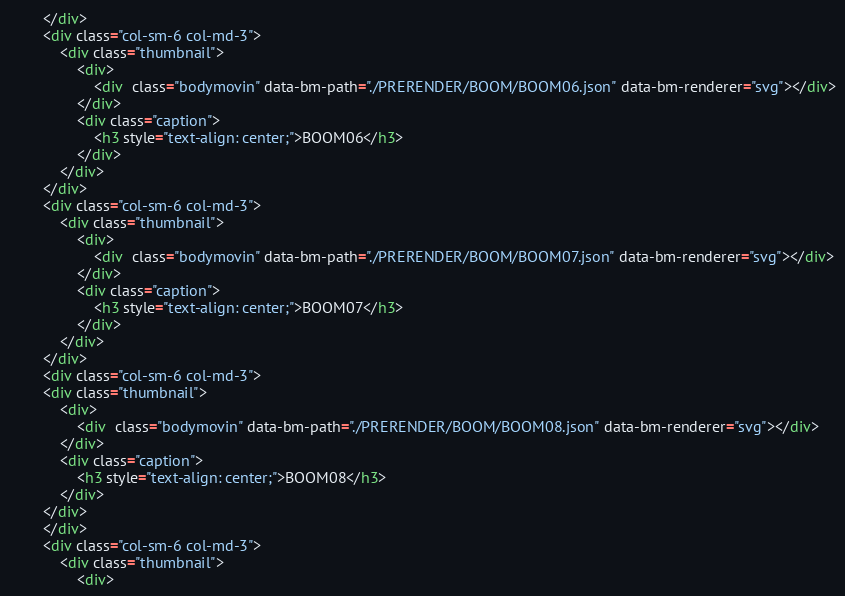Convert code to text. <code><loc_0><loc_0><loc_500><loc_500><_HTML_>        </div>
        <div class="col-sm-6 col-md-3">
            <div class="thumbnail">
                <div>
                    <div  class="bodymovin" data-bm-path="./PRERENDER/BOOM/BOOM06.json" data-bm-renderer="svg"></div>
                </div>
                <div class="caption">
                    <h3 style="text-align: center;">BOOM06</h3>
                </div>
            </div>
        </div>
        <div class="col-sm-6 col-md-3">
            <div class="thumbnail">
                <div>
                    <div  class="bodymovin" data-bm-path="./PRERENDER/BOOM/BOOM07.json" data-bm-renderer="svg"></div>
                </div>
                <div class="caption">
                    <h3 style="text-align: center;">BOOM07</h3>
                </div>
            </div>
        </div>
        <div class="col-sm-6 col-md-3">
        <div class="thumbnail">
            <div>
                <div  class="bodymovin" data-bm-path="./PRERENDER/BOOM/BOOM08.json" data-bm-renderer="svg"></div>
            </div>
            <div class="caption">
                <h3 style="text-align: center;">BOOM08</h3>
            </div>
        </div>
        </div>
        <div class="col-sm-6 col-md-3">
            <div class="thumbnail">
                <div></code> 